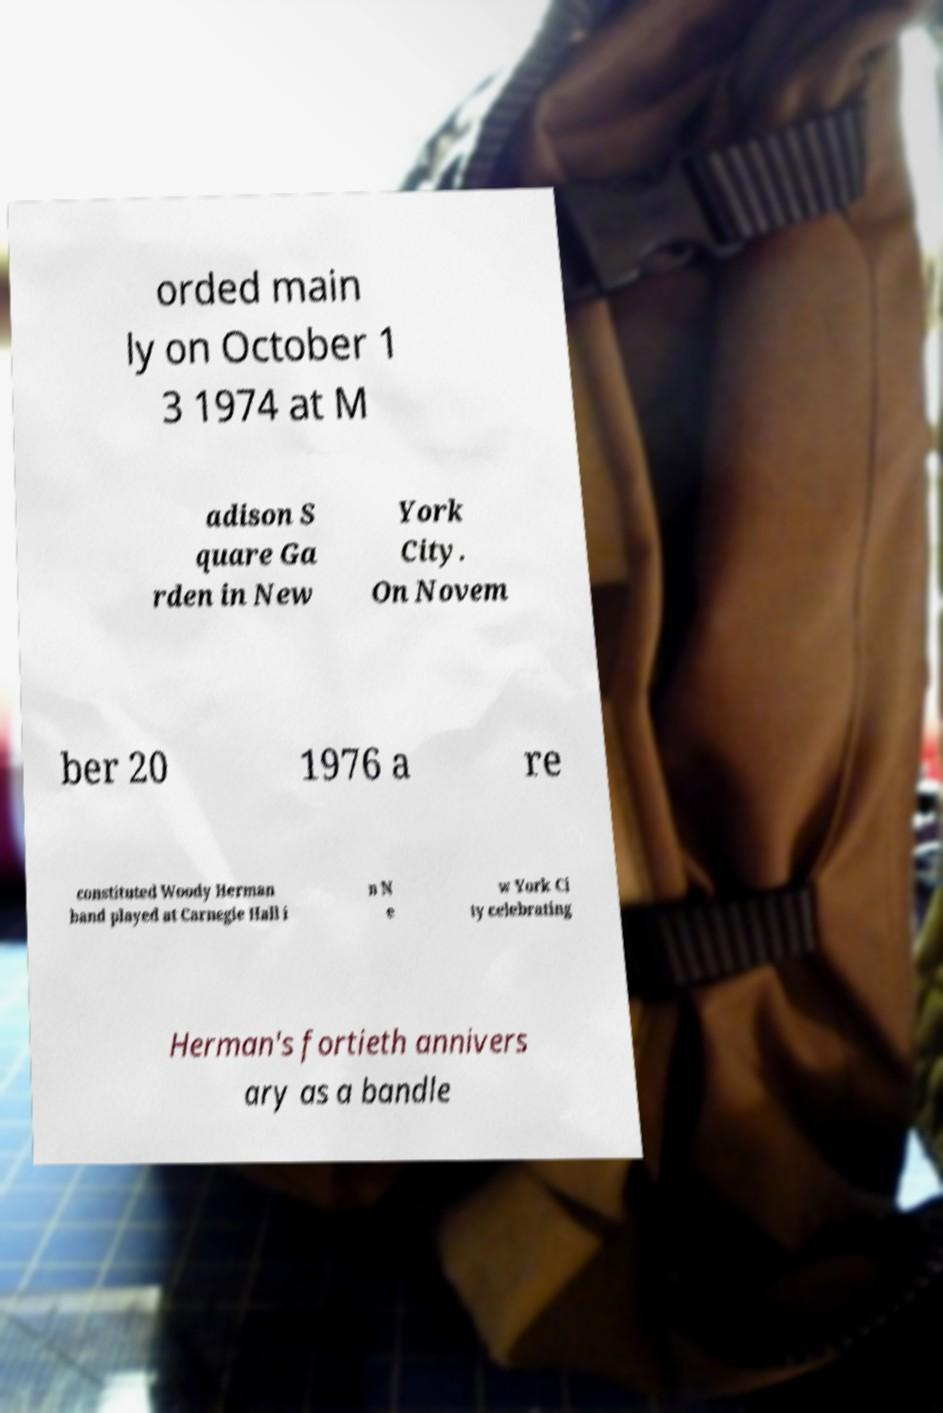Can you read and provide the text displayed in the image?This photo seems to have some interesting text. Can you extract and type it out for me? orded main ly on October 1 3 1974 at M adison S quare Ga rden in New York City. On Novem ber 20 1976 a re constituted Woody Herman band played at Carnegie Hall i n N e w York Ci ty celebrating Herman's fortieth annivers ary as a bandle 